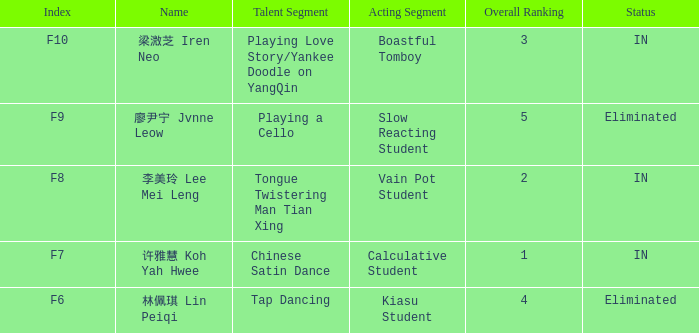Can you identify the talent segment in the event with index f9? Playing a Cello. Could you help me parse every detail presented in this table? {'header': ['Index', 'Name', 'Talent Segment', 'Acting Segment', 'Overall Ranking', 'Status'], 'rows': [['F10', '梁溦芝 Iren Neo', 'Playing Love Story/Yankee Doodle on YangQin', 'Boastful Tomboy', '3', 'IN'], ['F9', '廖尹宁 Jvnne Leow', 'Playing a Cello', 'Slow Reacting Student', '5', 'Eliminated'], ['F8', '李美玲 Lee Mei Leng', 'Tongue Twistering Man Tian Xing', 'Vain Pot Student', '2', 'IN'], ['F7', '许雅慧 Koh Yah Hwee', 'Chinese Satin Dance', 'Calculative Student', '1', 'IN'], ['F6', '林佩琪 Lin Peiqi', 'Tap Dancing', 'Kiasu Student', '4', 'Eliminated']]} 